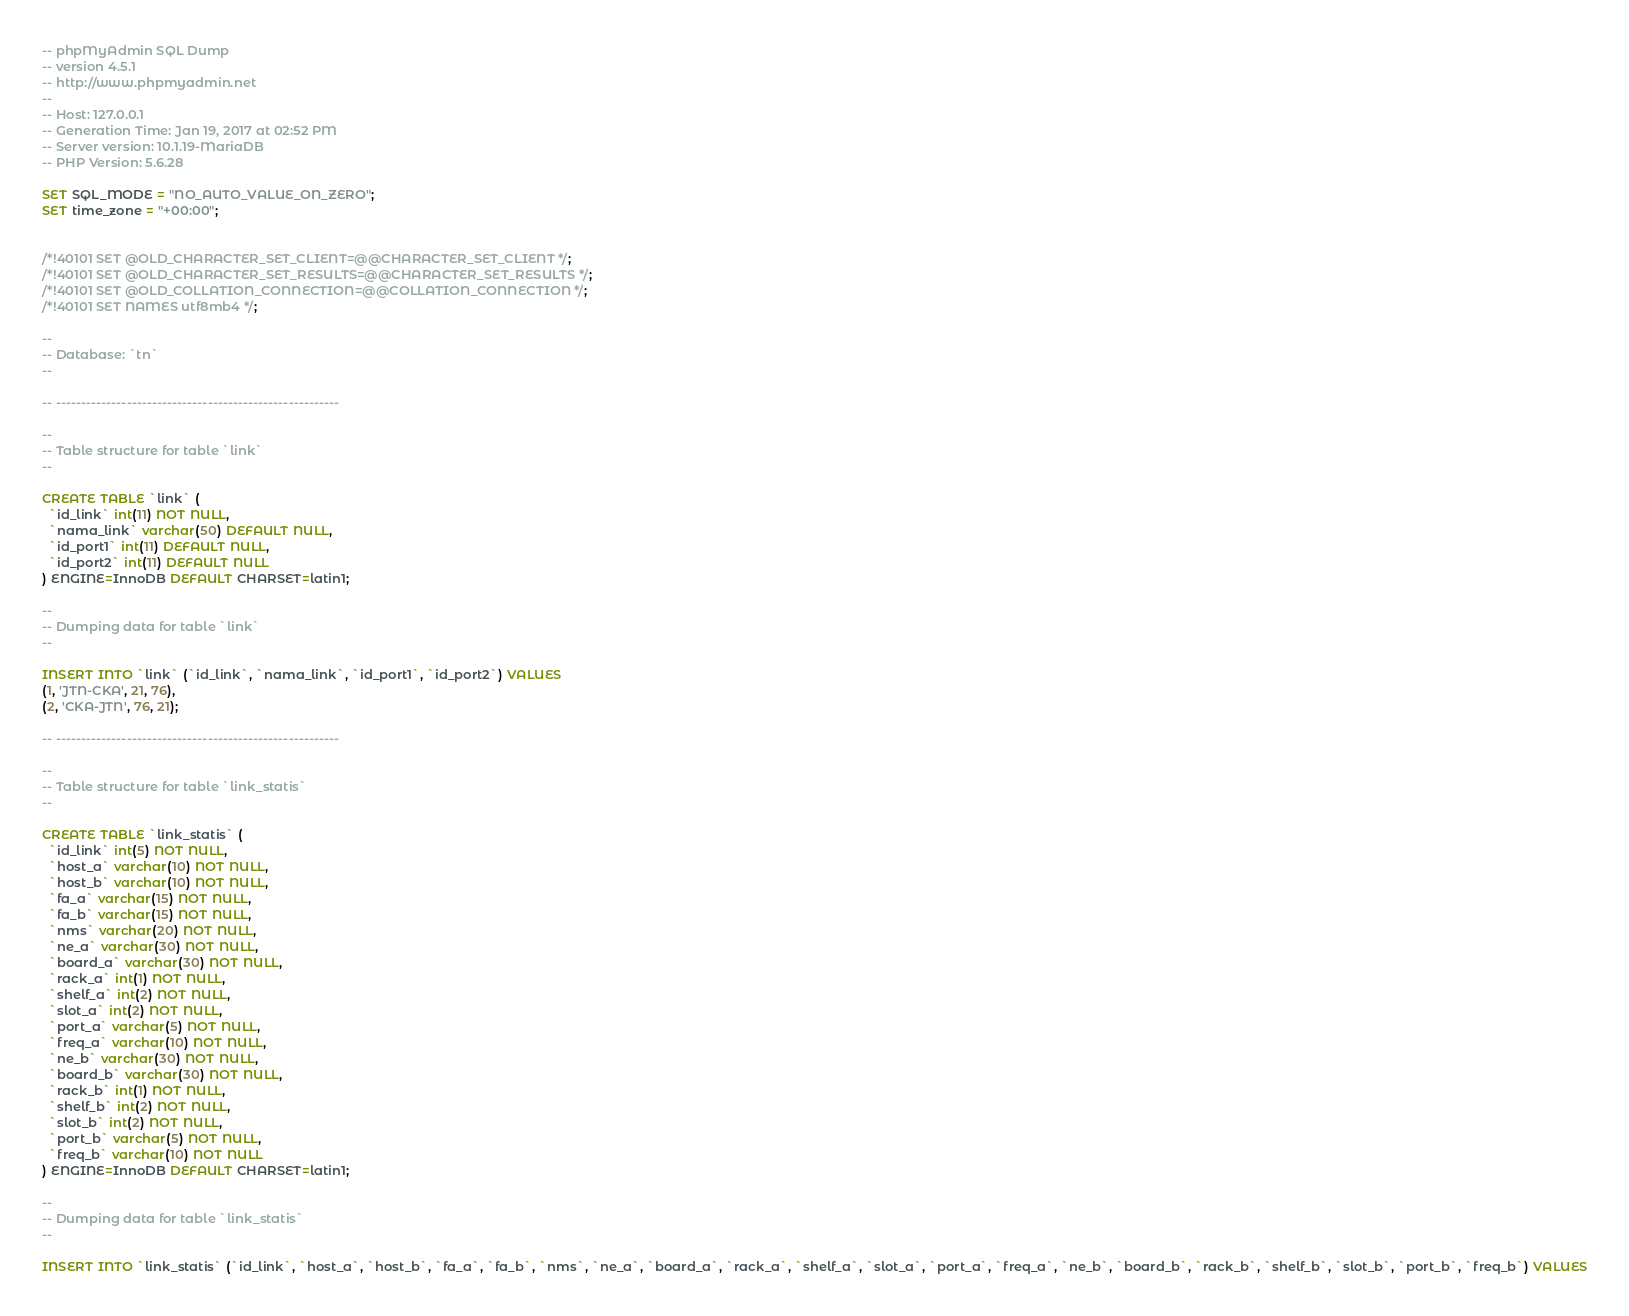Convert code to text. <code><loc_0><loc_0><loc_500><loc_500><_SQL_>-- phpMyAdmin SQL Dump
-- version 4.5.1
-- http://www.phpmyadmin.net
--
-- Host: 127.0.0.1
-- Generation Time: Jan 19, 2017 at 02:52 PM
-- Server version: 10.1.19-MariaDB
-- PHP Version: 5.6.28

SET SQL_MODE = "NO_AUTO_VALUE_ON_ZERO";
SET time_zone = "+00:00";


/*!40101 SET @OLD_CHARACTER_SET_CLIENT=@@CHARACTER_SET_CLIENT */;
/*!40101 SET @OLD_CHARACTER_SET_RESULTS=@@CHARACTER_SET_RESULTS */;
/*!40101 SET @OLD_COLLATION_CONNECTION=@@COLLATION_CONNECTION */;
/*!40101 SET NAMES utf8mb4 */;

--
-- Database: `tn`
--

-- --------------------------------------------------------

--
-- Table structure for table `link`
--

CREATE TABLE `link` (
  `id_link` int(11) NOT NULL,
  `nama_link` varchar(50) DEFAULT NULL,
  `id_port1` int(11) DEFAULT NULL,
  `id_port2` int(11) DEFAULT NULL
) ENGINE=InnoDB DEFAULT CHARSET=latin1;

--
-- Dumping data for table `link`
--

INSERT INTO `link` (`id_link`, `nama_link`, `id_port1`, `id_port2`) VALUES
(1, 'JTN-CKA', 21, 76),
(2, 'CKA-JTN', 76, 21);

-- --------------------------------------------------------

--
-- Table structure for table `link_statis`
--

CREATE TABLE `link_statis` (
  `id_link` int(5) NOT NULL,
  `host_a` varchar(10) NOT NULL,
  `host_b` varchar(10) NOT NULL,
  `fa_a` varchar(15) NOT NULL,
  `fa_b` varchar(15) NOT NULL,
  `nms` varchar(20) NOT NULL,
  `ne_a` varchar(30) NOT NULL,
  `board_a` varchar(30) NOT NULL,
  `rack_a` int(1) NOT NULL,
  `shelf_a` int(2) NOT NULL,
  `slot_a` int(2) NOT NULL,
  `port_a` varchar(5) NOT NULL,
  `freq_a` varchar(10) NOT NULL,
  `ne_b` varchar(30) NOT NULL,
  `board_b` varchar(30) NOT NULL,
  `rack_b` int(1) NOT NULL,
  `shelf_b` int(2) NOT NULL,
  `slot_b` int(2) NOT NULL,
  `port_b` varchar(5) NOT NULL,
  `freq_b` varchar(10) NOT NULL
) ENGINE=InnoDB DEFAULT CHARSET=latin1;

--
-- Dumping data for table `link_statis`
--

INSERT INTO `link_statis` (`id_link`, `host_a`, `host_b`, `fa_a`, `fa_b`, `nms`, `ne_a`, `board_a`, `rack_a`, `shelf_a`, `slot_a`, `port_a`, `freq_a`, `ne_b`, `board_b`, `rack_b`, `shelf_b`, `slot_b`, `port_b`, `freq_b`) VALUES</code> 